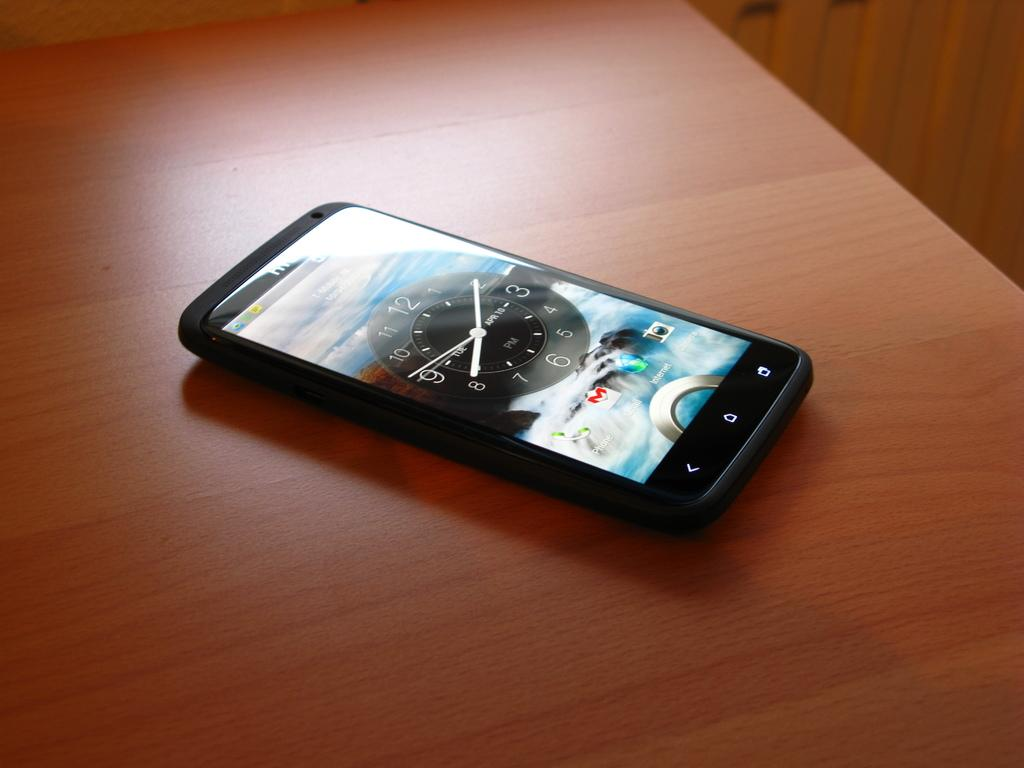<image>
Offer a succinct explanation of the picture presented. A smart phone placed on a table shows that the date is April 10th. 